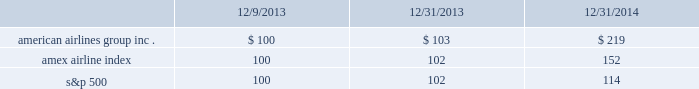Table of contents stock performance graph the following stock performance graph and related information shall not be deemed 201csoliciting material 201d or 201cfiled 201d with the securities and exchange commission , nor shall such information be incorporated by reference into any future filings under the securities act of 1933 or the exchange act , each as amended , except to the extent that we specifically incorporate it by reference into such filing .
The following stock performance graph compares our cumulative total shareholder return on an annual basis on our common stock with the cumulative total return on the standard and poor 2019s 500 stock index and the amex airline index from december 9 , 2013 ( the first trading day of aag common stock ) through december 31 , 2014 .
The comparison assumes $ 100 was invested on december 9 , 2013 in aag common stock and in each of the foregoing indices and assumes reinvestment of dividends .
The stock performance shown on the graph below represents historical stock performance and is not necessarily indicative of future stock price performance. .

What was the growth rate on the amex airline index from 12/31/2013 to 12/31/2014? 
Rationale: the growth rate is the recent period less the prior period divided by the prior
Computations: ((152 - 102) / 102)
Answer: 0.4902. Table of contents stock performance graph the following stock performance graph and related information shall not be deemed 201csoliciting material 201d or 201cfiled 201d with the securities and exchange commission , nor shall such information be incorporated by reference into any future filings under the securities act of 1933 or the exchange act , each as amended , except to the extent that we specifically incorporate it by reference into such filing .
The following stock performance graph compares our cumulative total shareholder return on an annual basis on our common stock with the cumulative total return on the standard and poor 2019s 500 stock index and the amex airline index from december 9 , 2013 ( the first trading day of aag common stock ) through december 31 , 2014 .
The comparison assumes $ 100 was invested on december 9 , 2013 in aag common stock and in each of the foregoing indices and assumes reinvestment of dividends .
The stock performance shown on the graph below represents historical stock performance and is not necessarily indicative of future stock price performance. .

By how much did american airlines group inc . outperform the amex airline index over the 3 year period? 
Computations: (((219 - 100) / 100) - ((152 - 100) / 100))
Answer: 0.67. 